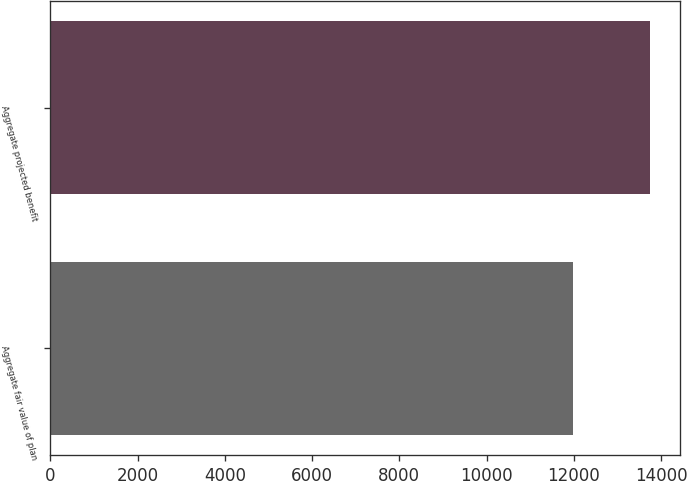<chart> <loc_0><loc_0><loc_500><loc_500><bar_chart><fcel>Aggregate fair value of plan<fcel>Aggregate projected benefit<nl><fcel>11979<fcel>13756<nl></chart> 